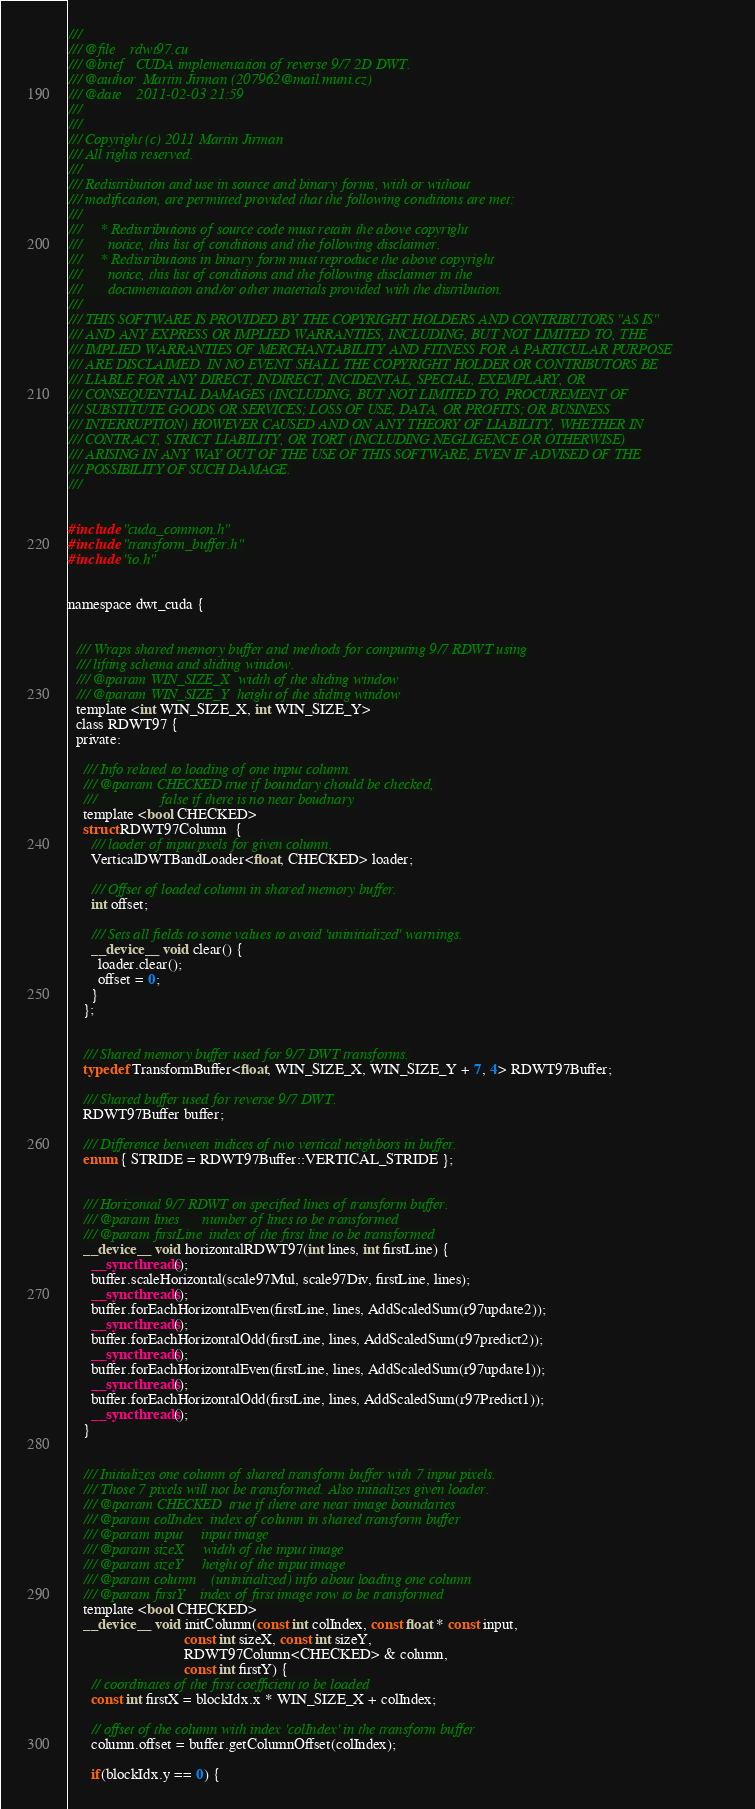<code> <loc_0><loc_0><loc_500><loc_500><_Cuda_>/// 
/// @file    rdwt97.cu
/// @brief   CUDA implementation of reverse 9/7 2D DWT.
/// @author  Martin Jirman (207962@mail.muni.cz)
/// @date    2011-02-03 21:59
///
///
/// Copyright (c) 2011 Martin Jirman
/// All rights reserved.
/// 
/// Redistribution and use in source and binary forms, with or without
/// modification, are permitted provided that the following conditions are met:
/// 
///     * Redistributions of source code must retain the above copyright
///       notice, this list of conditions and the following disclaimer.
///     * Redistributions in binary form must reproduce the above copyright
///       notice, this list of conditions and the following disclaimer in the
///       documentation and/or other materials provided with the distribution.
/// 
/// THIS SOFTWARE IS PROVIDED BY THE COPYRIGHT HOLDERS AND CONTRIBUTORS "AS IS"
/// AND ANY EXPRESS OR IMPLIED WARRANTIES, INCLUDING, BUT NOT LIMITED TO, THE
/// IMPLIED WARRANTIES OF MERCHANTABILITY AND FITNESS FOR A PARTICULAR PURPOSE
/// ARE DISCLAIMED. IN NO EVENT SHALL THE COPYRIGHT HOLDER OR CONTRIBUTORS BE
/// LIABLE FOR ANY DIRECT, INDIRECT, INCIDENTAL, SPECIAL, EXEMPLARY, OR
/// CONSEQUENTIAL DAMAGES (INCLUDING, BUT NOT LIMITED TO, PROCUREMENT OF
/// SUBSTITUTE GOODS OR SERVICES; LOSS OF USE, DATA, OR PROFITS; OR BUSINESS
/// INTERRUPTION) HOWEVER CAUSED AND ON ANY THEORY OF LIABILITY, WHETHER IN
/// CONTRACT, STRICT LIABILITY, OR TORT (INCLUDING NEGLIGENCE OR OTHERWISE)
/// ARISING IN ANY WAY OUT OF THE USE OF THIS SOFTWARE, EVEN IF ADVISED OF THE
/// POSSIBILITY OF SUCH DAMAGE.
///


#include "cuda_common.h"
#include "transform_buffer.h"
#include "io.h"


namespace dwt_cuda {

  
  /// Wraps shared memory buffer and methods for computing 9/7 RDWT using
  /// lifting schema and sliding window.
  /// @tparam WIN_SIZE_X  width of the sliding window
  /// @tparam WIN_SIZE_Y  height of the sliding window
  template <int WIN_SIZE_X, int WIN_SIZE_Y>
  class RDWT97 {
  private:
    
    /// Info related to loading of one input column.
    /// @tparam CHECKED true if boundary chould be checked,
    ///                 false if there is no near boudnary
    template <bool CHECKED>
    struct RDWT97Column  {
      /// laoder of input pxels for given column.
      VerticalDWTBandLoader<float, CHECKED> loader;
      
      /// Offset of loaded column in shared memory buffer.
      int offset;
      
      /// Sets all fields to some values to avoid 'uninitialized' warnings.
      __device__ void clear() {
        loader.clear();
        offset = 0;
      }
    };


    /// Shared memory buffer used for 9/7 DWT transforms.
    typedef TransformBuffer<float, WIN_SIZE_X, WIN_SIZE_Y + 7, 4> RDWT97Buffer;

    /// Shared buffer used for reverse 9/7 DWT.
    RDWT97Buffer buffer;

    /// Difference between indices of two vertical neighbors in buffer.
    enum { STRIDE = RDWT97Buffer::VERTICAL_STRIDE };


    /// Horizontal 9/7 RDWT on specified lines of transform buffer.
    /// @param lines      number of lines to be transformed
    /// @param firstLine  index of the first line to be transformed
    __device__ void horizontalRDWT97(int lines, int firstLine) {
      __syncthreads();
      buffer.scaleHorizontal(scale97Mul, scale97Div, firstLine, lines);
      __syncthreads();
      buffer.forEachHorizontalEven(firstLine, lines, AddScaledSum(r97update2));
      __syncthreads();
      buffer.forEachHorizontalOdd(firstLine, lines, AddScaledSum(r97predict2));
      __syncthreads();
      buffer.forEachHorizontalEven(firstLine, lines, AddScaledSum(r97update1));
      __syncthreads();
      buffer.forEachHorizontalOdd(firstLine, lines, AddScaledSum(r97Predict1));
      __syncthreads();
    }


    /// Initializes one column of shared transform buffer with 7 input pixels.
    /// Those 7 pixels will not be transformed. Also initializes given loader.
    /// @tparam CHECKED  true if there are near image boundaries
    /// @param colIndex  index of column in shared transform buffer
    /// @param input     input image
    /// @param sizeX     width of the input image
    /// @param sizeY     height of the input image
    /// @param column    (uninitialized) info about loading one column
    /// @param firstY    index of first image row to be transformed
    template <bool CHECKED>
    __device__ void initColumn(const int colIndex, const float * const input, 
                               const int sizeX, const int sizeY,
                               RDWT97Column<CHECKED> & column,
                               const int firstY) {
      // coordinates of the first coefficient to be loaded
      const int firstX = blockIdx.x * WIN_SIZE_X + colIndex;

      // offset of the column with index 'colIndex' in the transform buffer
      column.offset = buffer.getColumnOffset(colIndex);

      if(blockIdx.y == 0) {</code> 